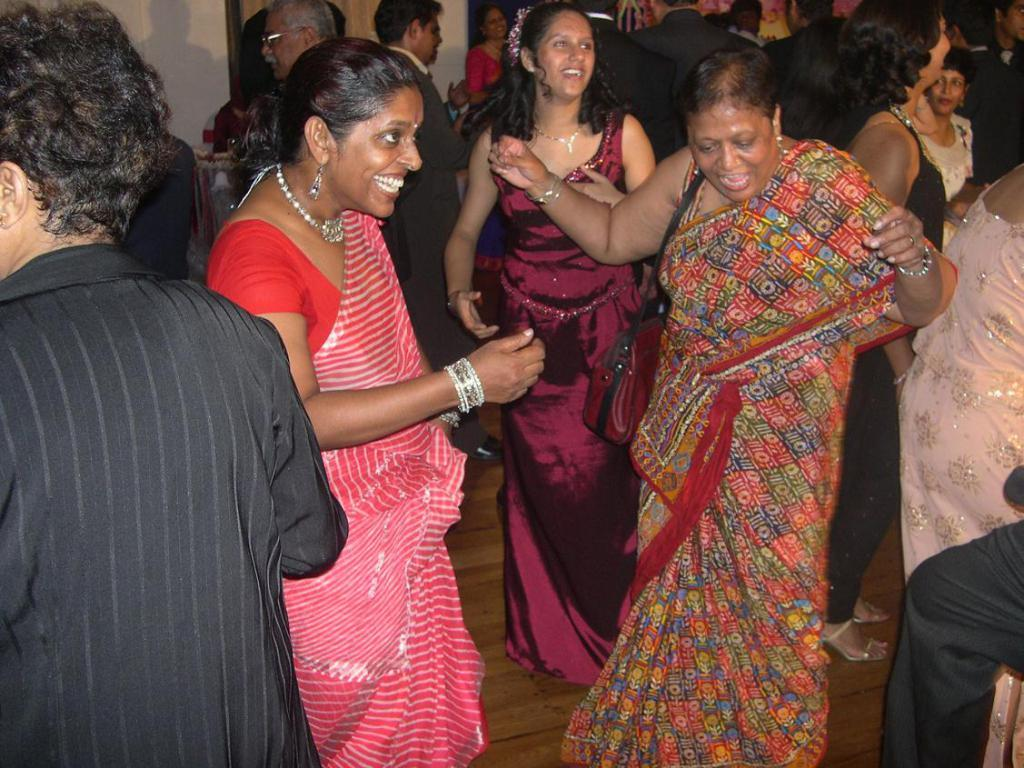Who is present in the image? There are people in the image. Where are the people located? The people are in a room. What is one of the people doing in the image? There is a woman dancing in the image. On which side of the image is the dancing woman? The woman is on the right side of the image. What type of birds can be seen flying in the image? There are no birds present in the image; it features people in a room. What is the governor's role in the image? There is no mention of a governor in the image, as it only shows people in a room. 